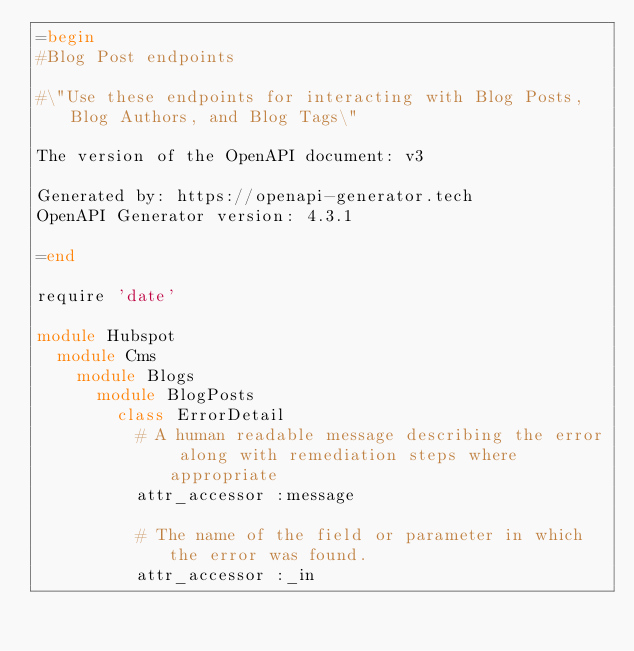Convert code to text. <code><loc_0><loc_0><loc_500><loc_500><_Ruby_>=begin
#Blog Post endpoints

#\"Use these endpoints for interacting with Blog Posts, Blog Authors, and Blog Tags\"

The version of the OpenAPI document: v3

Generated by: https://openapi-generator.tech
OpenAPI Generator version: 4.3.1

=end

require 'date'

module Hubspot
  module Cms
    module Blogs
      module BlogPosts
        class ErrorDetail
          # A human readable message describing the error along with remediation steps where appropriate
          attr_accessor :message

          # The name of the field or parameter in which the error was found.
          attr_accessor :_in
</code> 